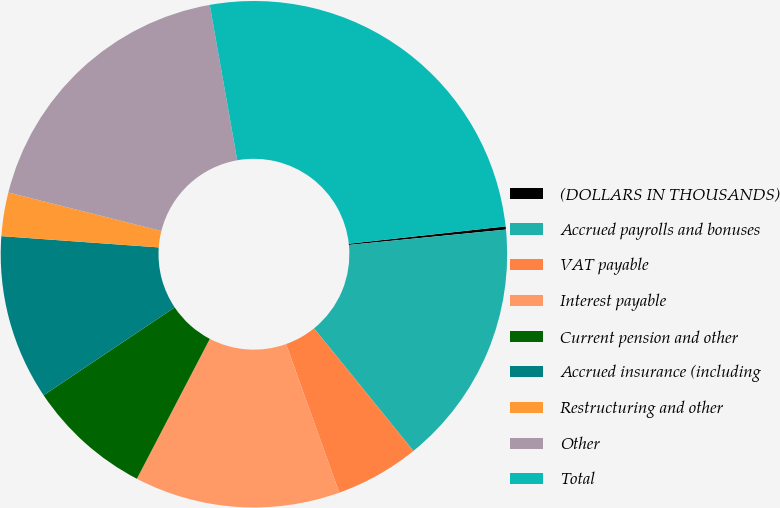Convert chart. <chart><loc_0><loc_0><loc_500><loc_500><pie_chart><fcel>(DOLLARS IN THOUSANDS)<fcel>Accrued payrolls and bonuses<fcel>VAT payable<fcel>Interest payable<fcel>Current pension and other<fcel>Accrued insurance (including<fcel>Restructuring and other<fcel>Other<fcel>Total<nl><fcel>0.2%<fcel>15.71%<fcel>5.37%<fcel>13.12%<fcel>7.95%<fcel>10.54%<fcel>2.78%<fcel>18.29%<fcel>26.04%<nl></chart> 